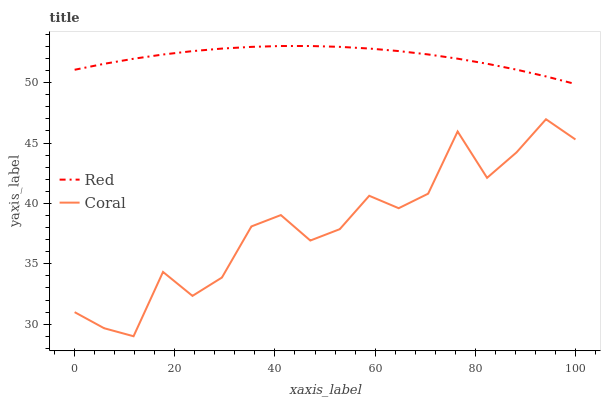Does Coral have the minimum area under the curve?
Answer yes or no. Yes. Does Red have the maximum area under the curve?
Answer yes or no. Yes. Does Red have the minimum area under the curve?
Answer yes or no. No. Is Red the smoothest?
Answer yes or no. Yes. Is Coral the roughest?
Answer yes or no. Yes. Is Red the roughest?
Answer yes or no. No. Does Coral have the lowest value?
Answer yes or no. Yes. Does Red have the lowest value?
Answer yes or no. No. Does Red have the highest value?
Answer yes or no. Yes. Is Coral less than Red?
Answer yes or no. Yes. Is Red greater than Coral?
Answer yes or no. Yes. Does Coral intersect Red?
Answer yes or no. No. 